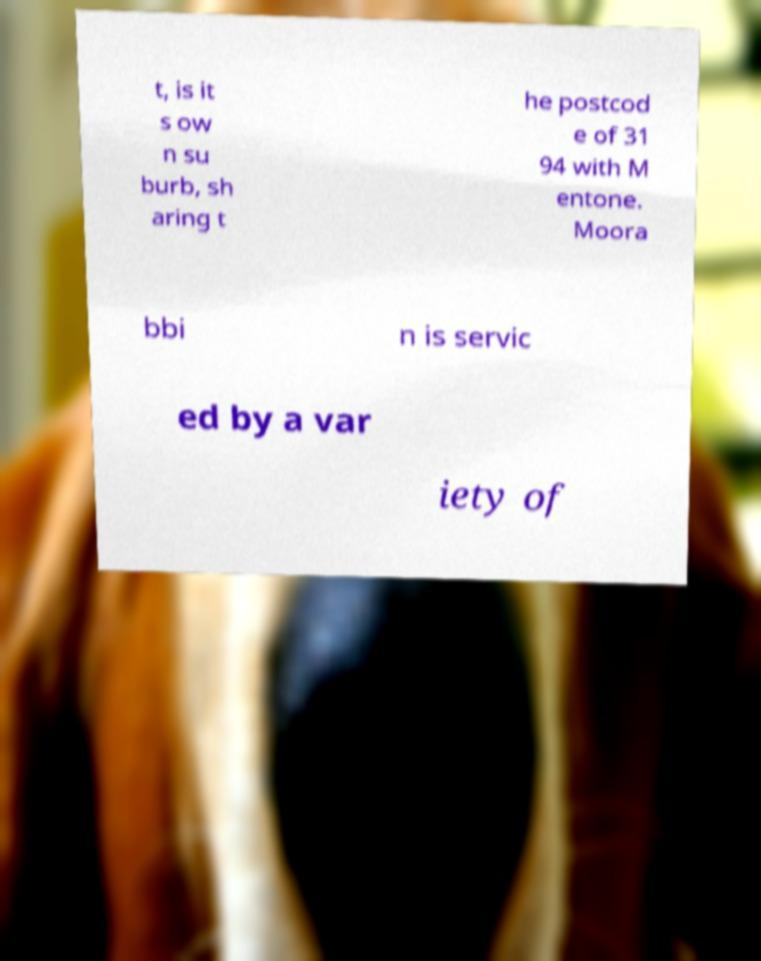Can you read and provide the text displayed in the image?This photo seems to have some interesting text. Can you extract and type it out for me? t, is it s ow n su burb, sh aring t he postcod e of 31 94 with M entone. Moora bbi n is servic ed by a var iety of 